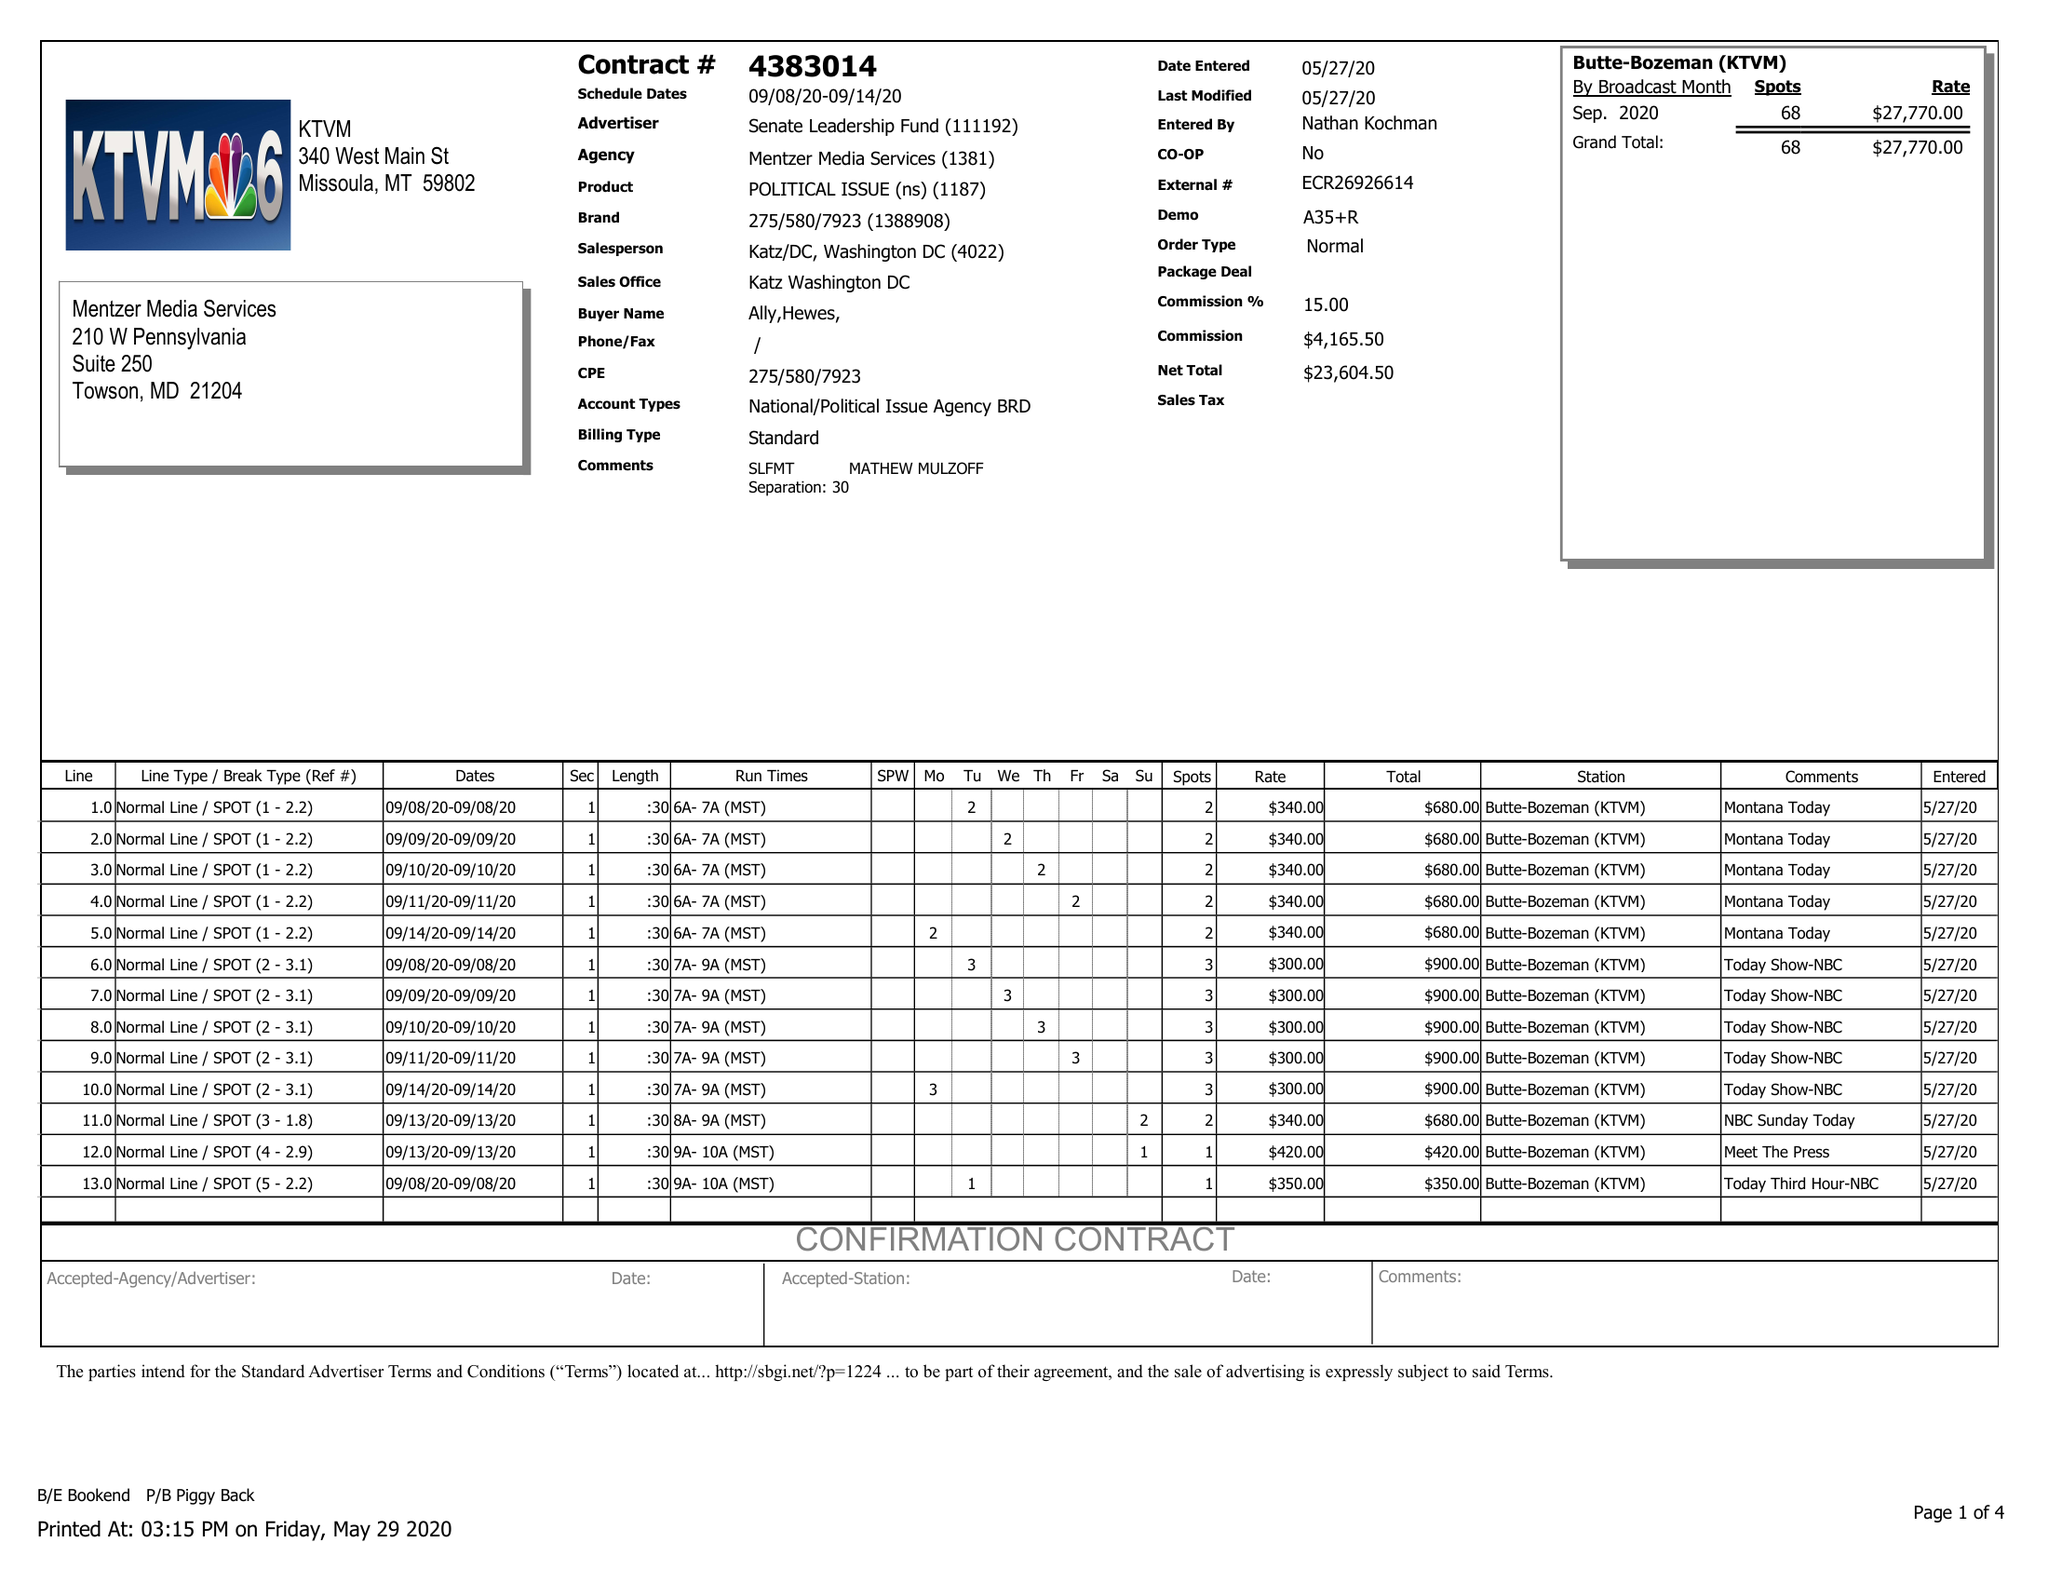What is the value for the gross_amount?
Answer the question using a single word or phrase. 27770.00 